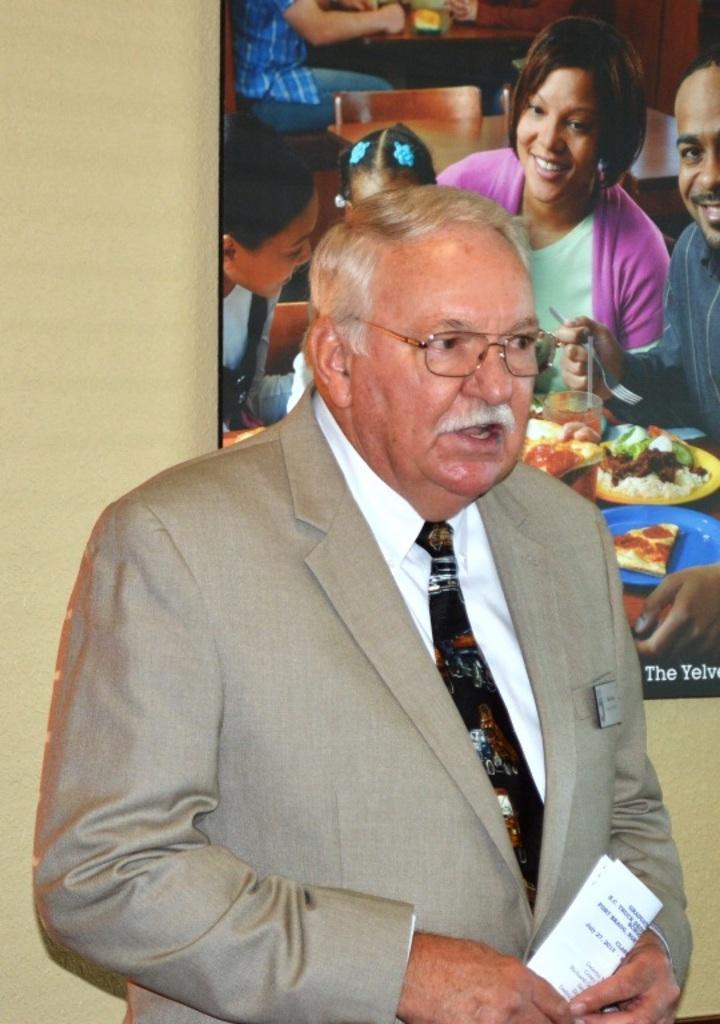In one or two sentences, can you explain what this image depicts? In this picture we can see a person, he is holding a paper and in the background we can see a wall, photo frame, here we can see people, chairs, food and some objects. 